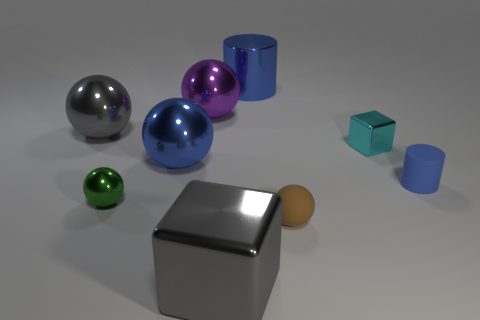Can you tell me the different materials that these objects might be made from? The objects appear to be made of different materials. The large and small squares look metallic, possibly steel or aluminum, while the spheres have a reflective surface that could suggest a polished metal or glass. The objects with matte finishes could be made of plastic or ceramic. 